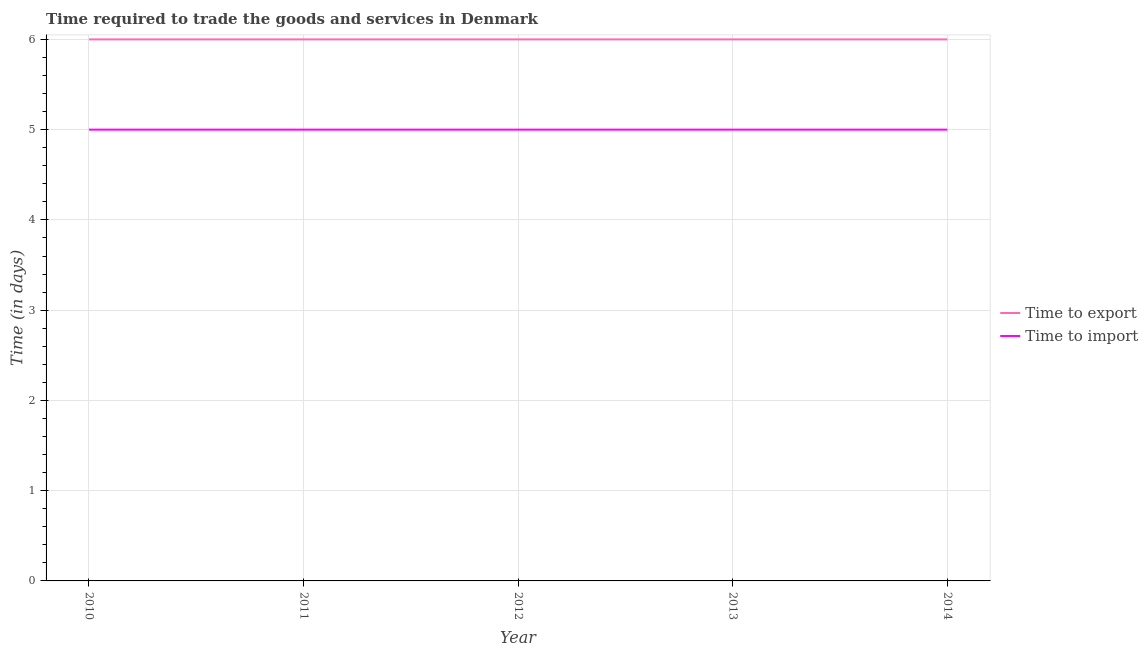How many different coloured lines are there?
Provide a short and direct response. 2. Is the number of lines equal to the number of legend labels?
Keep it short and to the point. Yes. What is the time to import in 2013?
Keep it short and to the point. 5. Across all years, what is the maximum time to import?
Provide a succinct answer. 5. Across all years, what is the minimum time to import?
Your answer should be compact. 5. In which year was the time to import minimum?
Offer a very short reply. 2010. What is the total time to export in the graph?
Your answer should be compact. 30. What is the difference between the time to export in 2010 and that in 2011?
Ensure brevity in your answer.  0. What is the difference between the time to import in 2012 and the time to export in 2014?
Your answer should be compact. -1. What is the average time to export per year?
Provide a short and direct response. 6. In the year 2012, what is the difference between the time to export and time to import?
Give a very brief answer. 1. In how many years, is the time to import greater than 2.8 days?
Offer a terse response. 5. Is the time to import in 2012 less than that in 2013?
Provide a succinct answer. No. Is the difference between the time to export in 2010 and 2012 greater than the difference between the time to import in 2010 and 2012?
Provide a short and direct response. No. Is the sum of the time to export in 2011 and 2012 greater than the maximum time to import across all years?
Provide a short and direct response. Yes. Is the time to import strictly greater than the time to export over the years?
Your answer should be very brief. No. Is the time to import strictly less than the time to export over the years?
Your answer should be compact. Yes. How many years are there in the graph?
Offer a very short reply. 5. Are the values on the major ticks of Y-axis written in scientific E-notation?
Your answer should be compact. No. Does the graph contain grids?
Ensure brevity in your answer.  Yes. Where does the legend appear in the graph?
Provide a succinct answer. Center right. How are the legend labels stacked?
Give a very brief answer. Vertical. What is the title of the graph?
Give a very brief answer. Time required to trade the goods and services in Denmark. Does "State government" appear as one of the legend labels in the graph?
Offer a very short reply. No. What is the label or title of the X-axis?
Offer a terse response. Year. What is the label or title of the Y-axis?
Provide a short and direct response. Time (in days). What is the Time (in days) in Time to export in 2010?
Your answer should be compact. 6. What is the Time (in days) in Time to export in 2011?
Your answer should be compact. 6. What is the Time (in days) in Time to import in 2013?
Your response must be concise. 5. What is the Time (in days) of Time to import in 2014?
Your answer should be very brief. 5. Across all years, what is the minimum Time (in days) of Time to export?
Give a very brief answer. 6. Across all years, what is the minimum Time (in days) of Time to import?
Provide a short and direct response. 5. What is the difference between the Time (in days) of Time to export in 2010 and that in 2012?
Provide a succinct answer. 0. What is the difference between the Time (in days) of Time to export in 2010 and that in 2013?
Offer a very short reply. 0. What is the difference between the Time (in days) of Time to import in 2010 and that in 2013?
Offer a very short reply. 0. What is the difference between the Time (in days) of Time to export in 2010 and that in 2014?
Your answer should be very brief. 0. What is the difference between the Time (in days) in Time to export in 2011 and that in 2012?
Your response must be concise. 0. What is the difference between the Time (in days) in Time to import in 2011 and that in 2012?
Provide a succinct answer. 0. What is the difference between the Time (in days) of Time to export in 2011 and that in 2014?
Your answer should be very brief. 0. What is the difference between the Time (in days) of Time to export in 2012 and that in 2013?
Ensure brevity in your answer.  0. What is the difference between the Time (in days) of Time to import in 2012 and that in 2013?
Keep it short and to the point. 0. What is the difference between the Time (in days) of Time to import in 2012 and that in 2014?
Provide a succinct answer. 0. What is the difference between the Time (in days) of Time to export in 2010 and the Time (in days) of Time to import in 2011?
Offer a terse response. 1. What is the difference between the Time (in days) in Time to export in 2010 and the Time (in days) in Time to import in 2012?
Offer a terse response. 1. What is the difference between the Time (in days) of Time to export in 2010 and the Time (in days) of Time to import in 2014?
Keep it short and to the point. 1. What is the difference between the Time (in days) of Time to export in 2011 and the Time (in days) of Time to import in 2012?
Keep it short and to the point. 1. What is the difference between the Time (in days) of Time to export in 2013 and the Time (in days) of Time to import in 2014?
Offer a very short reply. 1. What is the average Time (in days) in Time to export per year?
Offer a terse response. 6. In the year 2010, what is the difference between the Time (in days) in Time to export and Time (in days) in Time to import?
Offer a very short reply. 1. In the year 2011, what is the difference between the Time (in days) in Time to export and Time (in days) in Time to import?
Your response must be concise. 1. In the year 2013, what is the difference between the Time (in days) of Time to export and Time (in days) of Time to import?
Make the answer very short. 1. What is the ratio of the Time (in days) of Time to export in 2010 to that in 2011?
Ensure brevity in your answer.  1. What is the ratio of the Time (in days) in Time to import in 2010 to that in 2011?
Your response must be concise. 1. What is the ratio of the Time (in days) of Time to export in 2010 to that in 2012?
Offer a terse response. 1. What is the ratio of the Time (in days) in Time to export in 2010 to that in 2013?
Offer a very short reply. 1. What is the ratio of the Time (in days) in Time to import in 2010 to that in 2014?
Your answer should be compact. 1. What is the ratio of the Time (in days) of Time to import in 2011 to that in 2012?
Your answer should be compact. 1. What is the ratio of the Time (in days) in Time to export in 2011 to that in 2013?
Make the answer very short. 1. What is the ratio of the Time (in days) of Time to export in 2011 to that in 2014?
Offer a very short reply. 1. What is the ratio of the Time (in days) of Time to import in 2012 to that in 2013?
Give a very brief answer. 1. What is the ratio of the Time (in days) of Time to export in 2013 to that in 2014?
Ensure brevity in your answer.  1. What is the difference between the highest and the second highest Time (in days) of Time to import?
Provide a succinct answer. 0. 